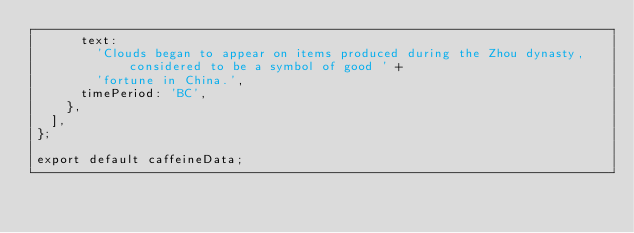Convert code to text. <code><loc_0><loc_0><loc_500><loc_500><_TypeScript_>      text:
        'Clouds began to appear on items produced during the Zhou dynasty, considered to be a symbol of good ' +
        'fortune in China.',
      timePeriod: 'BC',
    },
  ],
};

export default caffeineData;
</code> 